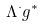<formula> <loc_0><loc_0><loc_500><loc_500>\Lambda ^ { \cdot } g ^ { * }</formula> 